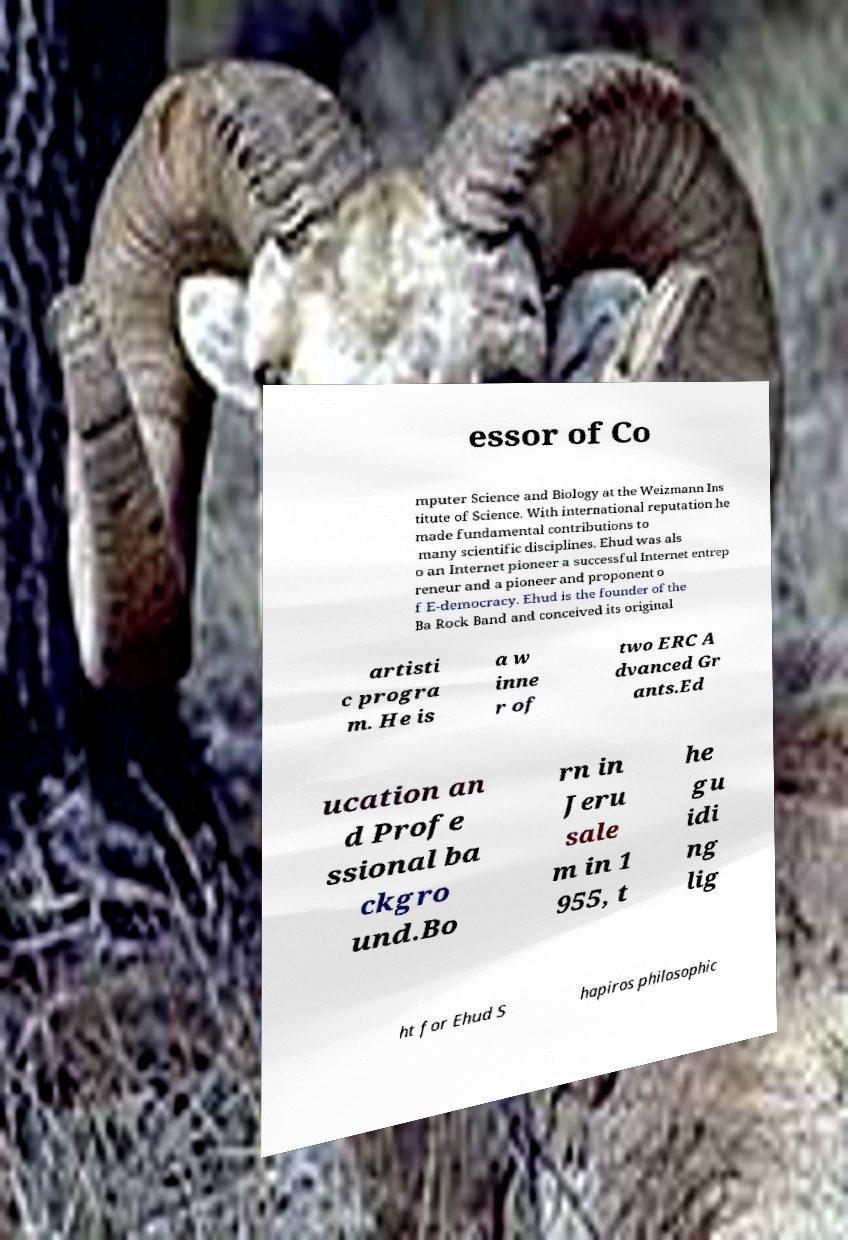There's text embedded in this image that I need extracted. Can you transcribe it verbatim? essor of Co mputer Science and Biology at the Weizmann Ins titute of Science. With international reputation he made fundamental contributions to many scientific disciplines. Ehud was als o an Internet pioneer a successful Internet entrep reneur and a pioneer and proponent o f E-democracy. Ehud is the founder of the Ba Rock Band and conceived its original artisti c progra m. He is a w inne r of two ERC A dvanced Gr ants.Ed ucation an d Profe ssional ba ckgro und.Bo rn in Jeru sale m in 1 955, t he gu idi ng lig ht for Ehud S hapiros philosophic 